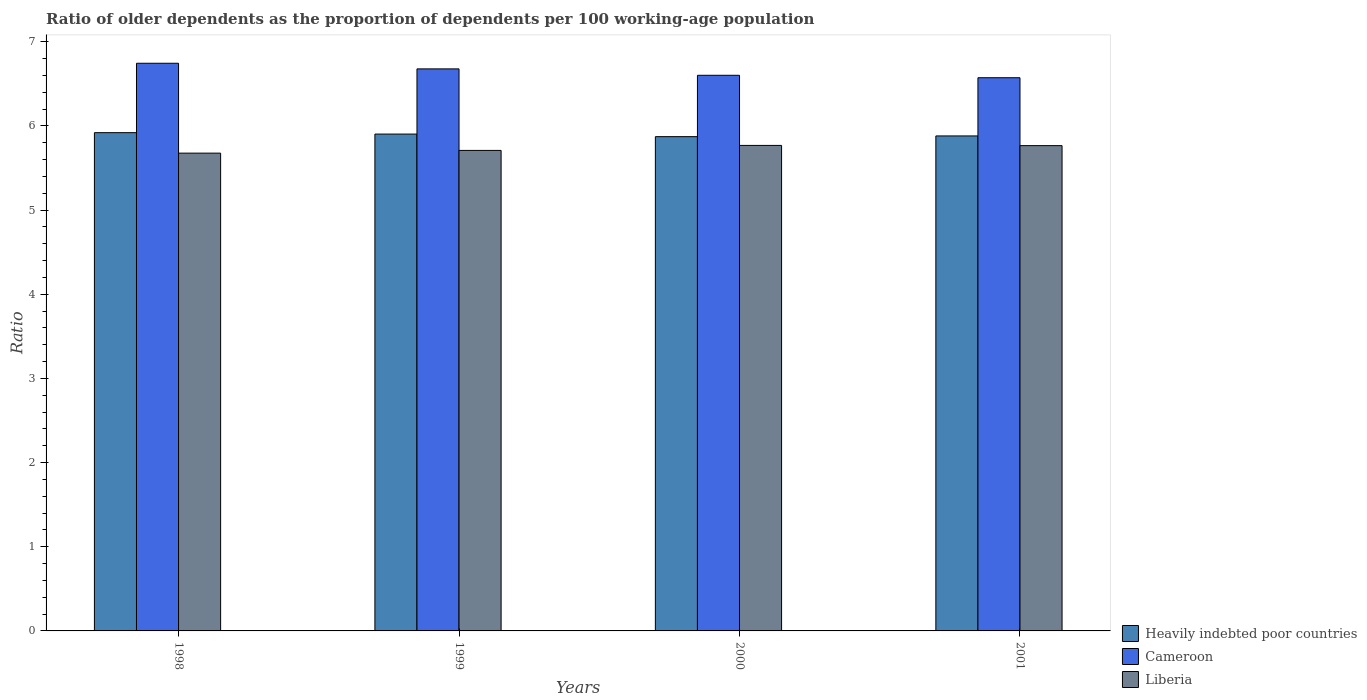Are the number of bars on each tick of the X-axis equal?
Provide a short and direct response. Yes. How many bars are there on the 1st tick from the left?
Offer a terse response. 3. How many bars are there on the 4th tick from the right?
Offer a terse response. 3. What is the age dependency ratio(old) in Cameroon in 1998?
Give a very brief answer. 6.75. Across all years, what is the maximum age dependency ratio(old) in Liberia?
Keep it short and to the point. 5.77. Across all years, what is the minimum age dependency ratio(old) in Liberia?
Make the answer very short. 5.68. In which year was the age dependency ratio(old) in Heavily indebted poor countries maximum?
Ensure brevity in your answer.  1998. In which year was the age dependency ratio(old) in Cameroon minimum?
Offer a very short reply. 2001. What is the total age dependency ratio(old) in Cameroon in the graph?
Your response must be concise. 26.6. What is the difference between the age dependency ratio(old) in Cameroon in 2000 and that in 2001?
Give a very brief answer. 0.03. What is the difference between the age dependency ratio(old) in Cameroon in 2000 and the age dependency ratio(old) in Heavily indebted poor countries in 2001?
Ensure brevity in your answer.  0.72. What is the average age dependency ratio(old) in Cameroon per year?
Provide a short and direct response. 6.65. In the year 2000, what is the difference between the age dependency ratio(old) in Liberia and age dependency ratio(old) in Heavily indebted poor countries?
Offer a terse response. -0.1. What is the ratio of the age dependency ratio(old) in Cameroon in 1999 to that in 2000?
Your answer should be very brief. 1.01. Is the age dependency ratio(old) in Heavily indebted poor countries in 1998 less than that in 2000?
Provide a short and direct response. No. Is the difference between the age dependency ratio(old) in Liberia in 1998 and 2000 greater than the difference between the age dependency ratio(old) in Heavily indebted poor countries in 1998 and 2000?
Keep it short and to the point. No. What is the difference between the highest and the second highest age dependency ratio(old) in Liberia?
Your answer should be very brief. 0. What is the difference between the highest and the lowest age dependency ratio(old) in Cameroon?
Offer a terse response. 0.17. Is the sum of the age dependency ratio(old) in Cameroon in 1999 and 2001 greater than the maximum age dependency ratio(old) in Heavily indebted poor countries across all years?
Ensure brevity in your answer.  Yes. What does the 2nd bar from the left in 2001 represents?
Your answer should be very brief. Cameroon. What does the 2nd bar from the right in 1998 represents?
Provide a succinct answer. Cameroon. Is it the case that in every year, the sum of the age dependency ratio(old) in Liberia and age dependency ratio(old) in Heavily indebted poor countries is greater than the age dependency ratio(old) in Cameroon?
Provide a succinct answer. Yes. What is the difference between two consecutive major ticks on the Y-axis?
Provide a succinct answer. 1. Are the values on the major ticks of Y-axis written in scientific E-notation?
Offer a very short reply. No. Does the graph contain any zero values?
Give a very brief answer. No. How many legend labels are there?
Offer a very short reply. 3. How are the legend labels stacked?
Ensure brevity in your answer.  Vertical. What is the title of the graph?
Give a very brief answer. Ratio of older dependents as the proportion of dependents per 100 working-age population. Does "Equatorial Guinea" appear as one of the legend labels in the graph?
Your answer should be very brief. No. What is the label or title of the X-axis?
Make the answer very short. Years. What is the label or title of the Y-axis?
Provide a succinct answer. Ratio. What is the Ratio of Heavily indebted poor countries in 1998?
Give a very brief answer. 5.92. What is the Ratio of Cameroon in 1998?
Ensure brevity in your answer.  6.75. What is the Ratio of Liberia in 1998?
Your answer should be very brief. 5.68. What is the Ratio in Heavily indebted poor countries in 1999?
Your answer should be very brief. 5.9. What is the Ratio in Cameroon in 1999?
Your response must be concise. 6.68. What is the Ratio of Liberia in 1999?
Offer a very short reply. 5.71. What is the Ratio in Heavily indebted poor countries in 2000?
Provide a succinct answer. 5.87. What is the Ratio in Cameroon in 2000?
Your response must be concise. 6.6. What is the Ratio of Liberia in 2000?
Your answer should be compact. 5.77. What is the Ratio of Heavily indebted poor countries in 2001?
Provide a short and direct response. 5.88. What is the Ratio of Cameroon in 2001?
Your response must be concise. 6.57. What is the Ratio in Liberia in 2001?
Offer a very short reply. 5.77. Across all years, what is the maximum Ratio in Heavily indebted poor countries?
Provide a short and direct response. 5.92. Across all years, what is the maximum Ratio in Cameroon?
Your response must be concise. 6.75. Across all years, what is the maximum Ratio in Liberia?
Provide a short and direct response. 5.77. Across all years, what is the minimum Ratio of Heavily indebted poor countries?
Your answer should be very brief. 5.87. Across all years, what is the minimum Ratio in Cameroon?
Make the answer very short. 6.57. Across all years, what is the minimum Ratio of Liberia?
Your answer should be compact. 5.68. What is the total Ratio of Heavily indebted poor countries in the graph?
Ensure brevity in your answer.  23.58. What is the total Ratio in Cameroon in the graph?
Your answer should be very brief. 26.6. What is the total Ratio in Liberia in the graph?
Make the answer very short. 22.92. What is the difference between the Ratio in Heavily indebted poor countries in 1998 and that in 1999?
Your answer should be very brief. 0.02. What is the difference between the Ratio of Cameroon in 1998 and that in 1999?
Your response must be concise. 0.07. What is the difference between the Ratio of Liberia in 1998 and that in 1999?
Offer a very short reply. -0.03. What is the difference between the Ratio of Heavily indebted poor countries in 1998 and that in 2000?
Ensure brevity in your answer.  0.05. What is the difference between the Ratio of Cameroon in 1998 and that in 2000?
Your answer should be compact. 0.14. What is the difference between the Ratio in Liberia in 1998 and that in 2000?
Make the answer very short. -0.09. What is the difference between the Ratio in Heavily indebted poor countries in 1998 and that in 2001?
Offer a terse response. 0.04. What is the difference between the Ratio of Cameroon in 1998 and that in 2001?
Your answer should be compact. 0.17. What is the difference between the Ratio of Liberia in 1998 and that in 2001?
Offer a terse response. -0.09. What is the difference between the Ratio of Heavily indebted poor countries in 1999 and that in 2000?
Make the answer very short. 0.03. What is the difference between the Ratio of Cameroon in 1999 and that in 2000?
Offer a terse response. 0.08. What is the difference between the Ratio of Liberia in 1999 and that in 2000?
Give a very brief answer. -0.06. What is the difference between the Ratio in Heavily indebted poor countries in 1999 and that in 2001?
Your answer should be very brief. 0.02. What is the difference between the Ratio of Cameroon in 1999 and that in 2001?
Ensure brevity in your answer.  0.11. What is the difference between the Ratio of Liberia in 1999 and that in 2001?
Provide a succinct answer. -0.06. What is the difference between the Ratio in Heavily indebted poor countries in 2000 and that in 2001?
Your response must be concise. -0.01. What is the difference between the Ratio in Cameroon in 2000 and that in 2001?
Your answer should be very brief. 0.03. What is the difference between the Ratio in Liberia in 2000 and that in 2001?
Provide a short and direct response. 0. What is the difference between the Ratio in Heavily indebted poor countries in 1998 and the Ratio in Cameroon in 1999?
Your answer should be compact. -0.76. What is the difference between the Ratio of Heavily indebted poor countries in 1998 and the Ratio of Liberia in 1999?
Make the answer very short. 0.21. What is the difference between the Ratio of Cameroon in 1998 and the Ratio of Liberia in 1999?
Make the answer very short. 1.04. What is the difference between the Ratio of Heavily indebted poor countries in 1998 and the Ratio of Cameroon in 2000?
Make the answer very short. -0.68. What is the difference between the Ratio of Heavily indebted poor countries in 1998 and the Ratio of Liberia in 2000?
Give a very brief answer. 0.15. What is the difference between the Ratio in Cameroon in 1998 and the Ratio in Liberia in 2000?
Your answer should be compact. 0.98. What is the difference between the Ratio in Heavily indebted poor countries in 1998 and the Ratio in Cameroon in 2001?
Give a very brief answer. -0.65. What is the difference between the Ratio of Heavily indebted poor countries in 1998 and the Ratio of Liberia in 2001?
Your response must be concise. 0.15. What is the difference between the Ratio in Cameroon in 1998 and the Ratio in Liberia in 2001?
Offer a terse response. 0.98. What is the difference between the Ratio in Heavily indebted poor countries in 1999 and the Ratio in Cameroon in 2000?
Your answer should be very brief. -0.7. What is the difference between the Ratio of Heavily indebted poor countries in 1999 and the Ratio of Liberia in 2000?
Keep it short and to the point. 0.13. What is the difference between the Ratio of Cameroon in 1999 and the Ratio of Liberia in 2000?
Provide a short and direct response. 0.91. What is the difference between the Ratio of Heavily indebted poor countries in 1999 and the Ratio of Cameroon in 2001?
Keep it short and to the point. -0.67. What is the difference between the Ratio of Heavily indebted poor countries in 1999 and the Ratio of Liberia in 2001?
Give a very brief answer. 0.14. What is the difference between the Ratio of Cameroon in 1999 and the Ratio of Liberia in 2001?
Make the answer very short. 0.91. What is the difference between the Ratio of Heavily indebted poor countries in 2000 and the Ratio of Liberia in 2001?
Make the answer very short. 0.11. What is the difference between the Ratio in Cameroon in 2000 and the Ratio in Liberia in 2001?
Provide a succinct answer. 0.84. What is the average Ratio of Heavily indebted poor countries per year?
Provide a succinct answer. 5.89. What is the average Ratio of Cameroon per year?
Offer a terse response. 6.65. What is the average Ratio of Liberia per year?
Make the answer very short. 5.73. In the year 1998, what is the difference between the Ratio of Heavily indebted poor countries and Ratio of Cameroon?
Your answer should be compact. -0.82. In the year 1998, what is the difference between the Ratio in Heavily indebted poor countries and Ratio in Liberia?
Your response must be concise. 0.24. In the year 1998, what is the difference between the Ratio of Cameroon and Ratio of Liberia?
Keep it short and to the point. 1.07. In the year 1999, what is the difference between the Ratio of Heavily indebted poor countries and Ratio of Cameroon?
Provide a succinct answer. -0.77. In the year 1999, what is the difference between the Ratio of Heavily indebted poor countries and Ratio of Liberia?
Offer a very short reply. 0.19. In the year 1999, what is the difference between the Ratio in Cameroon and Ratio in Liberia?
Ensure brevity in your answer.  0.97. In the year 2000, what is the difference between the Ratio in Heavily indebted poor countries and Ratio in Cameroon?
Your answer should be compact. -0.73. In the year 2000, what is the difference between the Ratio of Heavily indebted poor countries and Ratio of Liberia?
Provide a succinct answer. 0.1. In the year 2000, what is the difference between the Ratio of Cameroon and Ratio of Liberia?
Your answer should be very brief. 0.83. In the year 2001, what is the difference between the Ratio of Heavily indebted poor countries and Ratio of Cameroon?
Give a very brief answer. -0.69. In the year 2001, what is the difference between the Ratio of Heavily indebted poor countries and Ratio of Liberia?
Make the answer very short. 0.12. In the year 2001, what is the difference between the Ratio of Cameroon and Ratio of Liberia?
Offer a very short reply. 0.81. What is the ratio of the Ratio in Heavily indebted poor countries in 1998 to that in 1999?
Your response must be concise. 1. What is the ratio of the Ratio of Cameroon in 1998 to that in 2000?
Give a very brief answer. 1.02. What is the ratio of the Ratio in Liberia in 1998 to that in 2000?
Keep it short and to the point. 0.98. What is the ratio of the Ratio in Heavily indebted poor countries in 1998 to that in 2001?
Provide a short and direct response. 1.01. What is the ratio of the Ratio in Cameroon in 1998 to that in 2001?
Your response must be concise. 1.03. What is the ratio of the Ratio in Liberia in 1998 to that in 2001?
Provide a short and direct response. 0.98. What is the ratio of the Ratio of Heavily indebted poor countries in 1999 to that in 2000?
Ensure brevity in your answer.  1.01. What is the ratio of the Ratio in Cameroon in 1999 to that in 2000?
Make the answer very short. 1.01. What is the ratio of the Ratio of Heavily indebted poor countries in 1999 to that in 2001?
Ensure brevity in your answer.  1. What is the ratio of the Ratio in Cameroon in 1999 to that in 2001?
Your answer should be very brief. 1.02. What is the ratio of the Ratio in Liberia in 1999 to that in 2001?
Your response must be concise. 0.99. What is the ratio of the Ratio of Heavily indebted poor countries in 2000 to that in 2001?
Your response must be concise. 1. What is the difference between the highest and the second highest Ratio of Heavily indebted poor countries?
Offer a very short reply. 0.02. What is the difference between the highest and the second highest Ratio in Cameroon?
Provide a short and direct response. 0.07. What is the difference between the highest and the second highest Ratio of Liberia?
Your answer should be compact. 0. What is the difference between the highest and the lowest Ratio in Heavily indebted poor countries?
Ensure brevity in your answer.  0.05. What is the difference between the highest and the lowest Ratio of Cameroon?
Make the answer very short. 0.17. What is the difference between the highest and the lowest Ratio of Liberia?
Keep it short and to the point. 0.09. 